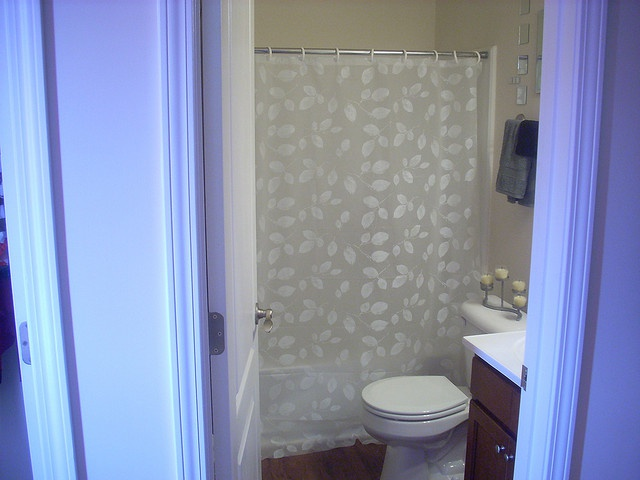Describe the objects in this image and their specific colors. I can see toilet in lightblue, darkgray, gray, and purple tones and sink in lavender, lightblue, and lightgray tones in this image. 